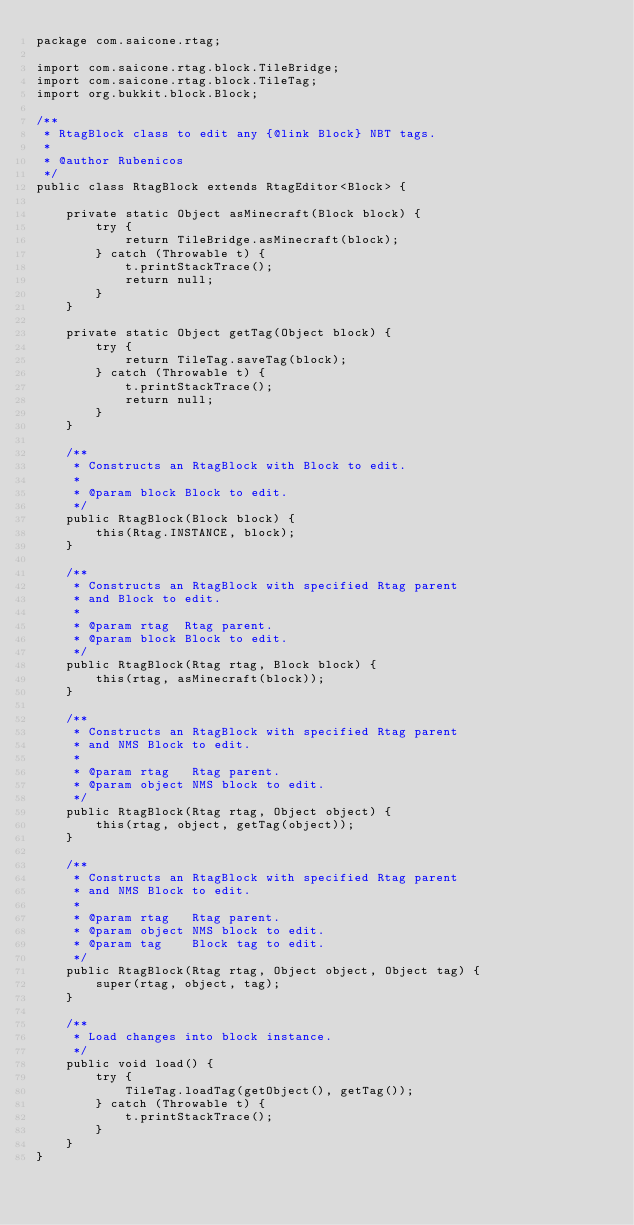<code> <loc_0><loc_0><loc_500><loc_500><_Java_>package com.saicone.rtag;

import com.saicone.rtag.block.TileBridge;
import com.saicone.rtag.block.TileTag;
import org.bukkit.block.Block;

/**
 * RtagBlock class to edit any {@link Block} NBT tags.
 *
 * @author Rubenicos
 */
public class RtagBlock extends RtagEditor<Block> {

    private static Object asMinecraft(Block block) {
        try {
            return TileBridge.asMinecraft(block);
        } catch (Throwable t) {
            t.printStackTrace();
            return null;
        }
    }

    private static Object getTag(Object block) {
        try {
            return TileTag.saveTag(block);
        } catch (Throwable t) {
            t.printStackTrace();
            return null;
        }
    }

    /**
     * Constructs an RtagBlock with Block to edit.
     *
     * @param block Block to edit.
     */
    public RtagBlock(Block block) {
        this(Rtag.INSTANCE, block);
    }

    /**
     * Constructs an RtagBlock with specified Rtag parent
     * and Block to edit.
     *
     * @param rtag  Rtag parent.
     * @param block Block to edit.
     */
    public RtagBlock(Rtag rtag, Block block) {
        this(rtag, asMinecraft(block));
    }

    /**
     * Constructs an RtagBlock with specified Rtag parent
     * and NMS Block to edit.
     *
     * @param rtag   Rtag parent.
     * @param object NMS block to edit.
     */
    public RtagBlock(Rtag rtag, Object object) {
        this(rtag, object, getTag(object));
    }

    /**
     * Constructs an RtagBlock with specified Rtag parent
     * and NMS Block to edit.
     *
     * @param rtag   Rtag parent.
     * @param object NMS block to edit.
     * @param tag    Block tag to edit.
     */
    public RtagBlock(Rtag rtag, Object object, Object tag) {
        super(rtag, object, tag);
    }

    /**
     * Load changes into block instance.
     */
    public void load() {
        try {
            TileTag.loadTag(getObject(), getTag());
        } catch (Throwable t) {
            t.printStackTrace();
        }
    }
}
</code> 